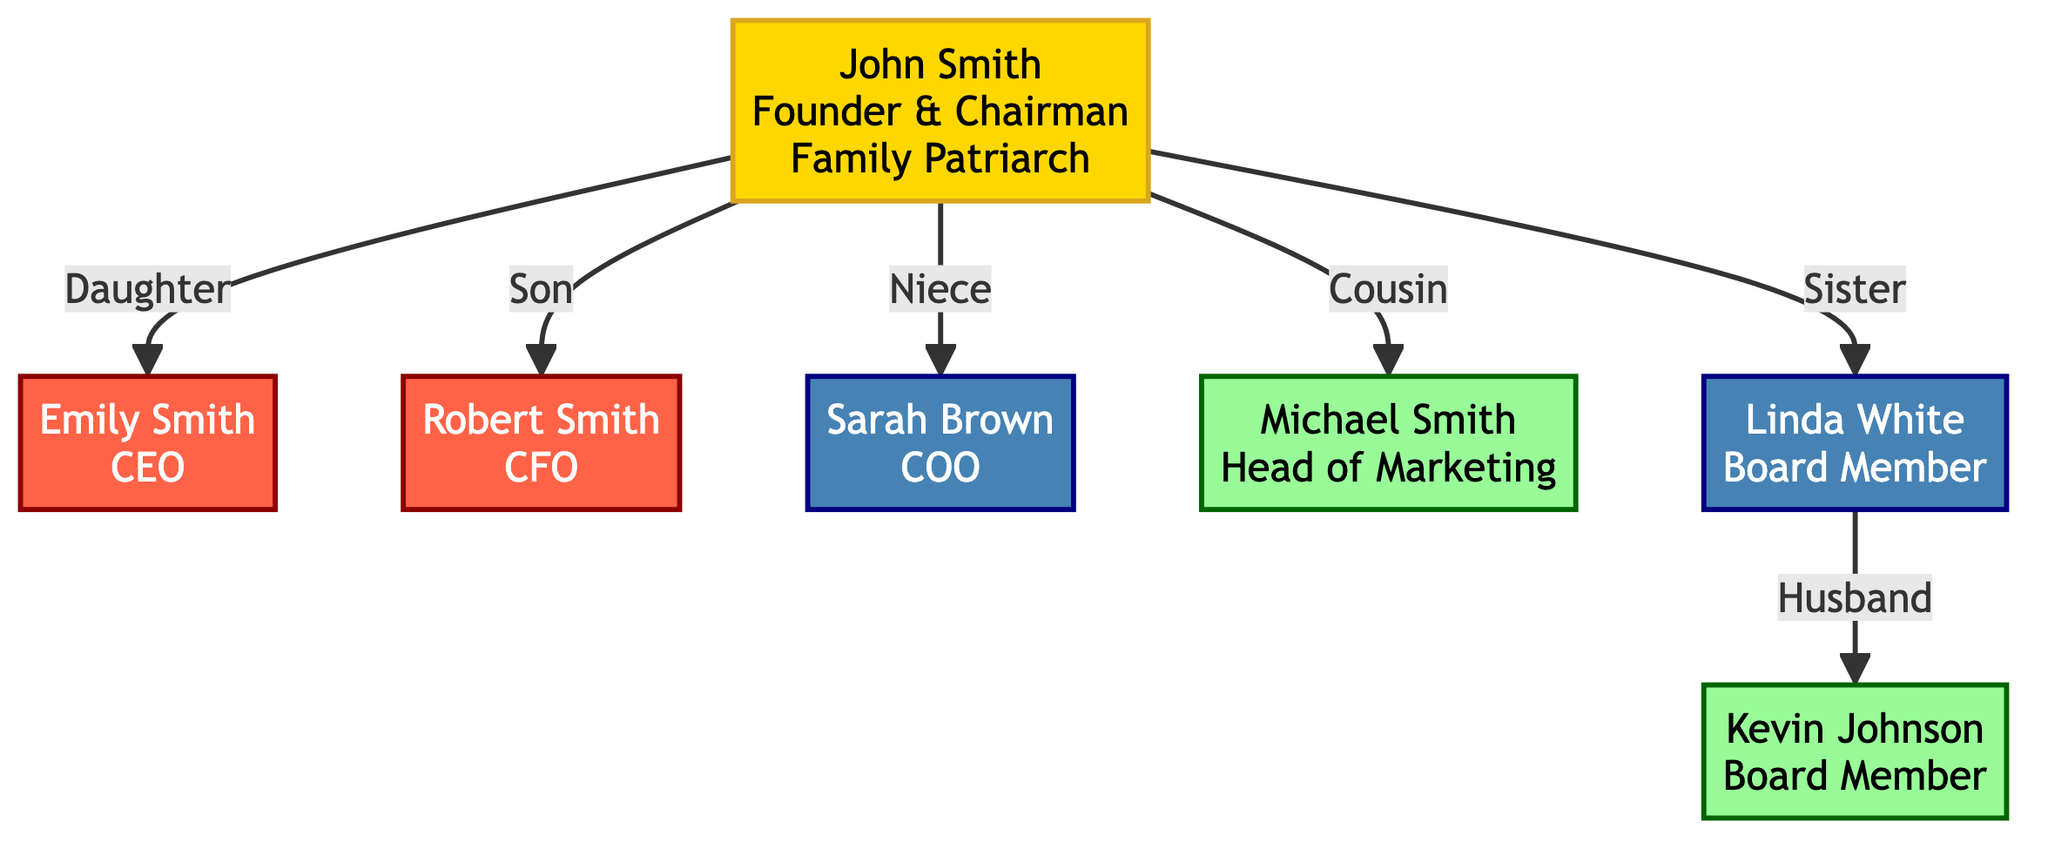What is John Smith's position in the company? The diagram identifies John Smith as "Founder & Chairman." This information is found directly within the node representing John Smith.
Answer: Founder & Chairman How many family members hold high influence? By examining the influence levels for each family member, it is evident that both John Smith and Emily Smith are classified as having high influence, indicating a total of two family members.
Answer: 2 Who is the Chief Financial Officer? The diagram specifies that Robert Smith is the Chief Financial Officer, which can be seen clearly within his labeled node.
Answer: Robert Smith What is the position of Linda White? The node corresponding to Linda White identifies her position as "Board Member." This information is directly indicated in the node associated with her.
Answer: Board Member Which family member serves as the Chief Operating Officer? The diagram clearly indicates that Sarah Brown holds the position of Chief Operating Officer, as stated in her node.
Answer: Sarah Brown What is the relationship between Kevin Johnson and Linda White? The flow of the diagram shows that Kevin Johnson is connected to Linda White through the label "Husband," which establishes their relationship in the family structure.
Answer: Husband Does Michael Smith have a higher influence than Robert Smith? Comparing the influence levels, Michael Smith is categorized as having low influence while Robert Smith's influence is labeled as medium, thus revealing that Robert Smith indeed has a higher influence.
Answer: No How many total nodes are in the diagram? Counting all distinct family members and the connections, the total number of nodes included in the diagram is seven, which constitutes the entire governance structure laid out.
Answer: 7 Which family member is the niece of John Smith? The diagram designates Sarah Brown as the niece of John Smith; this information is clearly stated in her node, establishing her family role.
Answer: Sarah Brown 